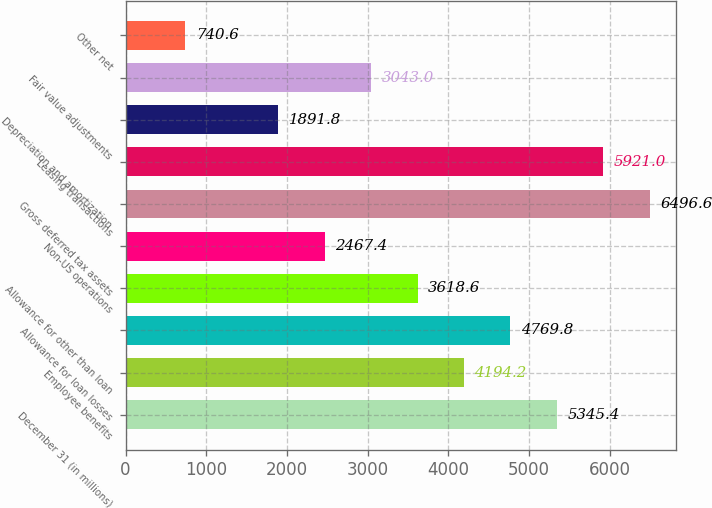Convert chart. <chart><loc_0><loc_0><loc_500><loc_500><bar_chart><fcel>December 31 (in millions)<fcel>Employee benefits<fcel>Allowance for loan losses<fcel>Allowance for other than loan<fcel>Non-US operations<fcel>Gross deferred tax assets<fcel>Leasing transactions<fcel>Depreciation and amortization<fcel>Fair value adjustments<fcel>Other net<nl><fcel>5345.4<fcel>4194.2<fcel>4769.8<fcel>3618.6<fcel>2467.4<fcel>6496.6<fcel>5921<fcel>1891.8<fcel>3043<fcel>740.6<nl></chart> 